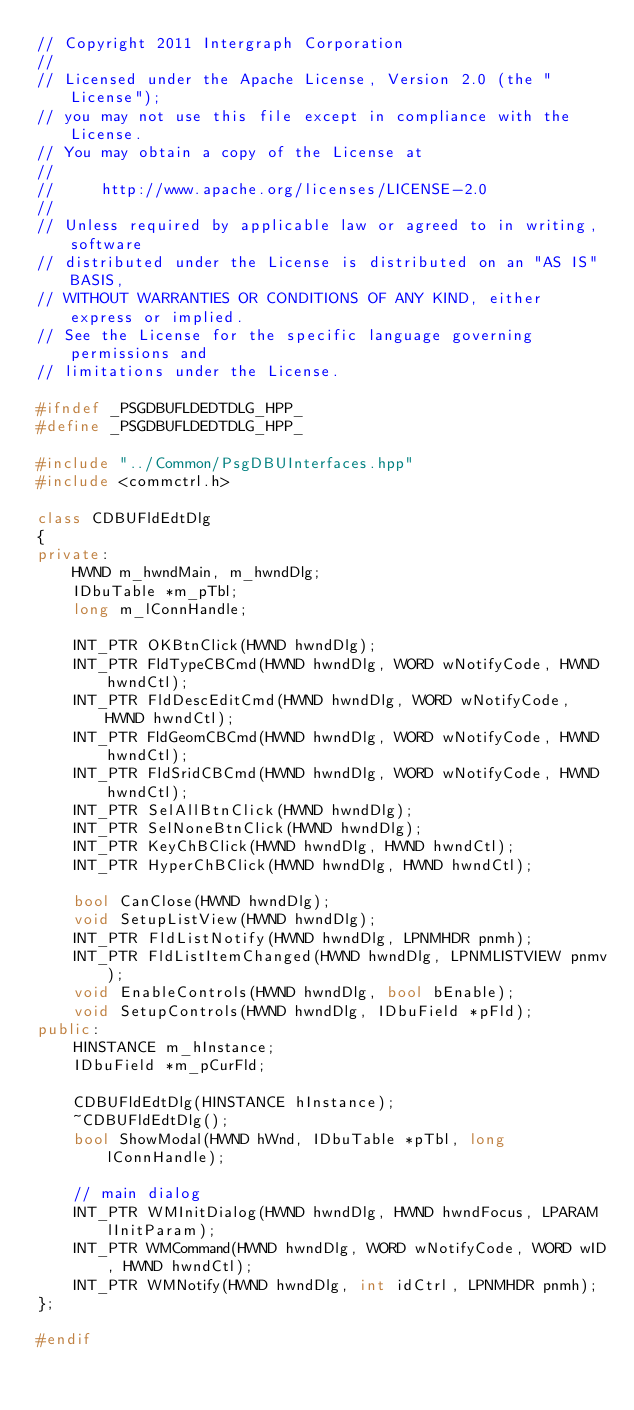<code> <loc_0><loc_0><loc_500><loc_500><_C++_>// Copyright 2011 Intergraph Corporation
//
// Licensed under the Apache License, Version 2.0 (the "License");
// you may not use this file except in compliance with the License.
// You may obtain a copy of the License at
//
//     http://www.apache.org/licenses/LICENSE-2.0
//
// Unless required by applicable law or agreed to in writing, software
// distributed under the License is distributed on an "AS IS" BASIS,
// WITHOUT WARRANTIES OR CONDITIONS OF ANY KIND, either express or implied.
// See the License for the specific language governing permissions and
// limitations under the License.

#ifndef _PSGDBUFLDEDTDLG_HPP_
#define _PSGDBUFLDEDTDLG_HPP_

#include "../Common/PsgDBUInterfaces.hpp"
#include <commctrl.h>

class CDBUFldEdtDlg
{
private:
    HWND m_hwndMain, m_hwndDlg;
    IDbuTable *m_pTbl;
    long m_lConnHandle;

    INT_PTR OKBtnClick(HWND hwndDlg);
    INT_PTR FldTypeCBCmd(HWND hwndDlg, WORD wNotifyCode, HWND hwndCtl);
    INT_PTR FldDescEditCmd(HWND hwndDlg, WORD wNotifyCode, HWND hwndCtl);
    INT_PTR FldGeomCBCmd(HWND hwndDlg, WORD wNotifyCode, HWND hwndCtl);
    INT_PTR FldSridCBCmd(HWND hwndDlg, WORD wNotifyCode, HWND hwndCtl);
    INT_PTR SelAllBtnClick(HWND hwndDlg);
    INT_PTR SelNoneBtnClick(HWND hwndDlg);
    INT_PTR KeyChBClick(HWND hwndDlg, HWND hwndCtl);
    INT_PTR HyperChBClick(HWND hwndDlg, HWND hwndCtl);

    bool CanClose(HWND hwndDlg);
    void SetupListView(HWND hwndDlg);
    INT_PTR FldListNotify(HWND hwndDlg, LPNMHDR pnmh);
    INT_PTR FldListItemChanged(HWND hwndDlg, LPNMLISTVIEW pnmv);
    void EnableControls(HWND hwndDlg, bool bEnable);
    void SetupControls(HWND hwndDlg, IDbuField *pFld);
public:
    HINSTANCE m_hInstance;
    IDbuField *m_pCurFld;

    CDBUFldEdtDlg(HINSTANCE hInstance);
    ~CDBUFldEdtDlg();
    bool ShowModal(HWND hWnd, IDbuTable *pTbl, long lConnHandle);

    // main dialog
    INT_PTR WMInitDialog(HWND hwndDlg, HWND hwndFocus, LPARAM lInitParam);
    INT_PTR WMCommand(HWND hwndDlg, WORD wNotifyCode, WORD wID, HWND hwndCtl);
    INT_PTR WMNotify(HWND hwndDlg, int idCtrl, LPNMHDR pnmh);
};

#endif
</code> 